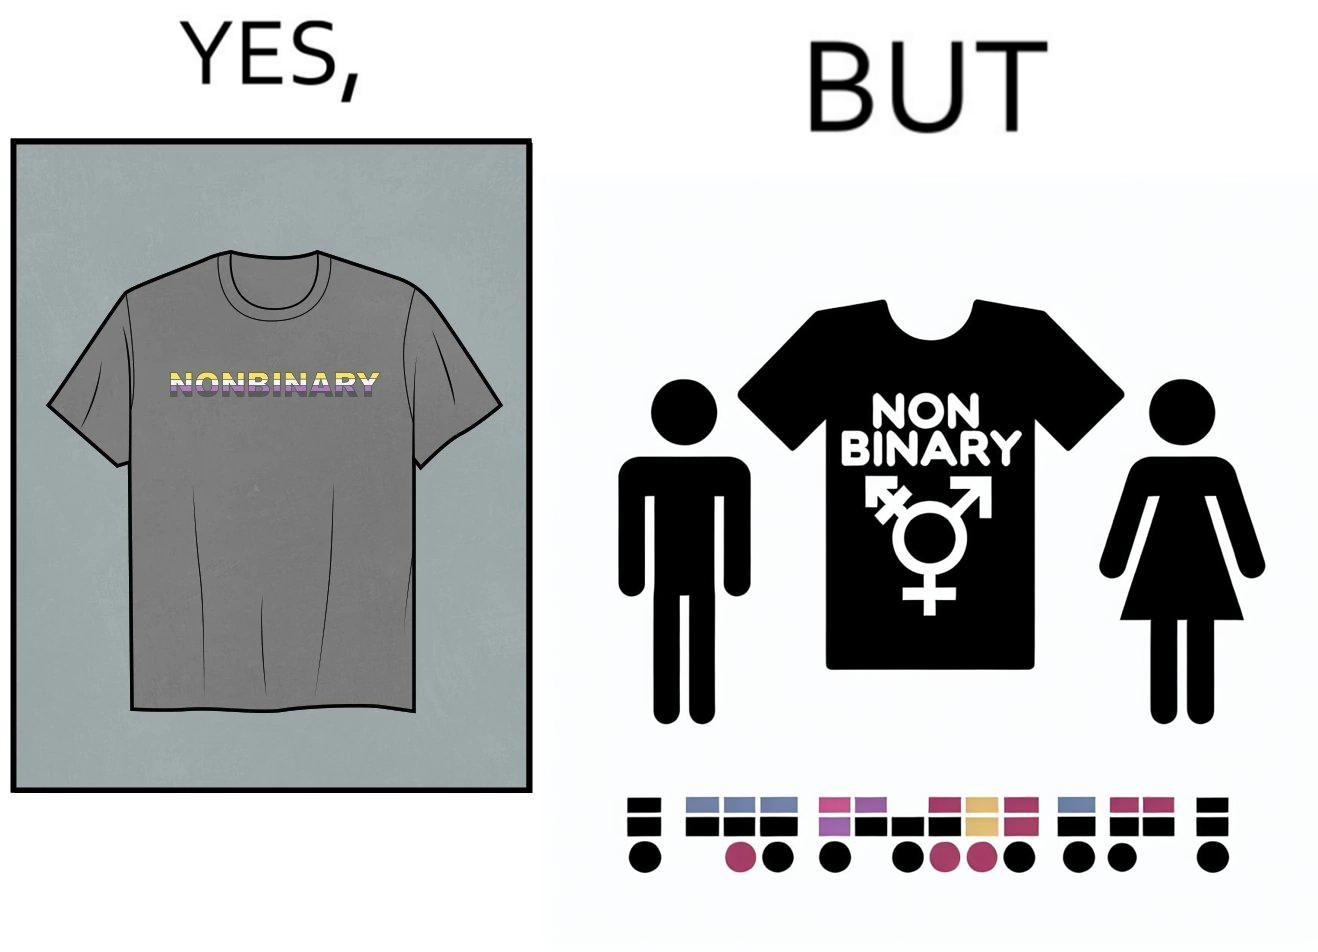Describe the content of this image. The image is ironic, as the t-shirt that says "NONBINARY" has only 2 options for gender on an online retail forum. 